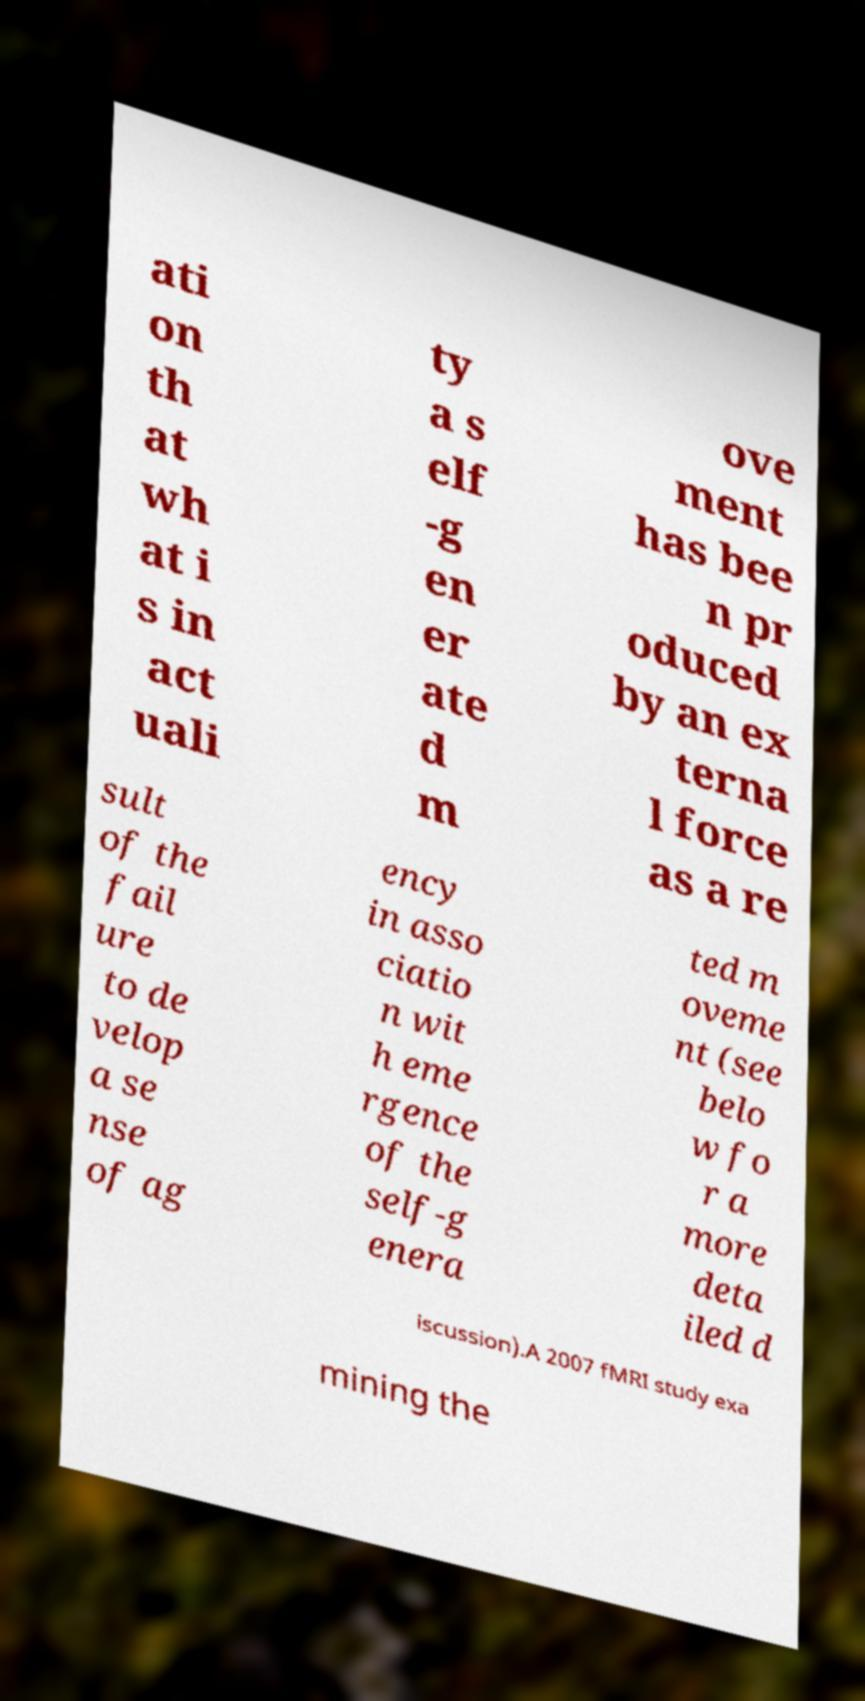Please read and relay the text visible in this image. What does it say? ati on th at wh at i s in act uali ty a s elf -g en er ate d m ove ment has bee n pr oduced by an ex terna l force as a re sult of the fail ure to de velop a se nse of ag ency in asso ciatio n wit h eme rgence of the self-g enera ted m oveme nt (see belo w fo r a more deta iled d iscussion).A 2007 fMRI study exa mining the 